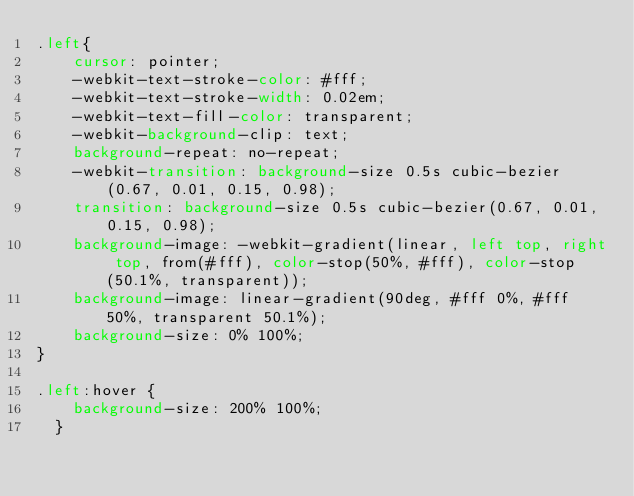Convert code to text. <code><loc_0><loc_0><loc_500><loc_500><_CSS_>.left{
    cursor: pointer;
    -webkit-text-stroke-color: #fff;
    -webkit-text-stroke-width: 0.02em;
    -webkit-text-fill-color: transparent;
    -webkit-background-clip: text;
    background-repeat: no-repeat;
    -webkit-transition: background-size 0.5s cubic-bezier(0.67, 0.01, 0.15, 0.98);
    transition: background-size 0.5s cubic-bezier(0.67, 0.01, 0.15, 0.98);
    background-image: -webkit-gradient(linear, left top, right top, from(#fff), color-stop(50%, #fff), color-stop(50.1%, transparent));
    background-image: linear-gradient(90deg, #fff 0%, #fff 50%, transparent 50.1%);
    background-size: 0% 100%;
}

.left:hover {
    background-size: 200% 100%;
  }</code> 